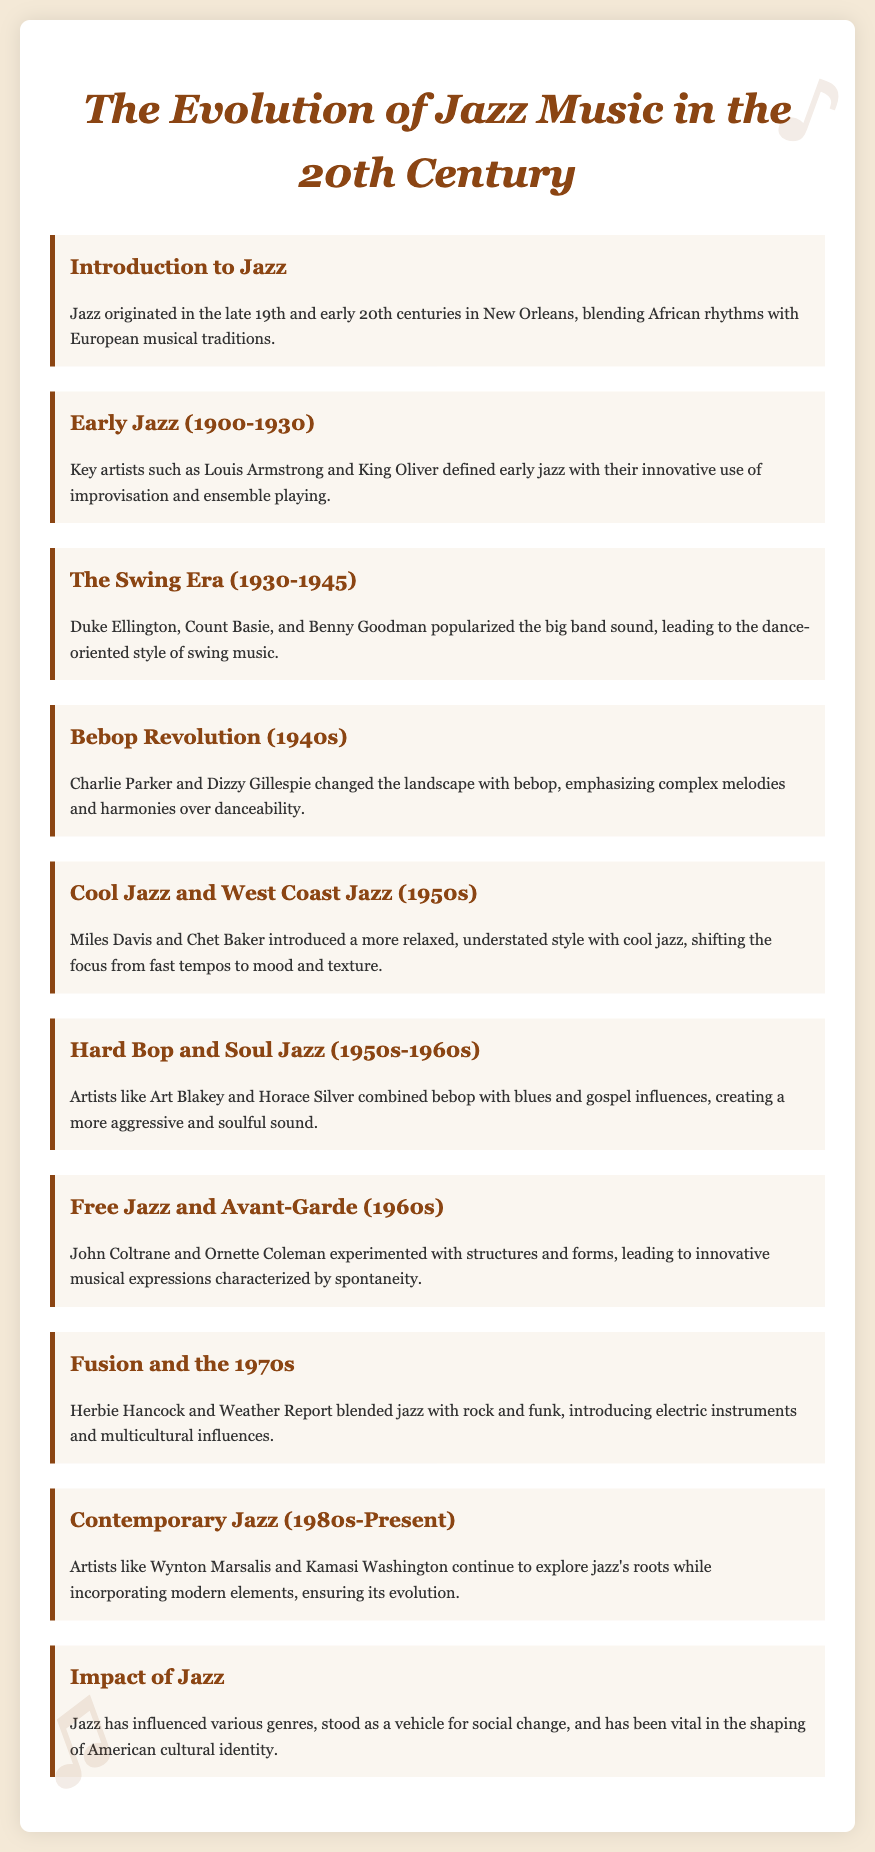What is the origin city of jazz? The document states that jazz originated in New Orleans.
Answer: New Orleans Who are two key artists of early jazz? The document mentions Louis Armstrong and King Oliver as key artists of early jazz.
Answer: Louis Armstrong and King Oliver What music style did Duke Ellington popularize? Duke Ellington is associated with the big band sound and dance-oriented style of swing music.
Answer: Swing Which two artists are known for the bebop revolution? The document lists Charlie Parker and Dizzy Gillespie as key figures in the bebop revolution.
Answer: Charlie Parker and Dizzy Gillespie What decade is associated with cool jazz? The document indicates that cool jazz emerged in the 1950s.
Answer: 1950s What musical elements did Herbie Hancock introduce in the 1970s? Herbie Hancock blended jazz with rock and funk and introduced electric instruments and multicultural influences.
Answer: Electric instruments and multicultural influences Name an artist linked to contemporary jazz. The document mentions Wynton Marsalis as a contemporary jazz artist.
Answer: Wynton Marsalis How has jazz influenced culture? Jazz is noted as a vehicle for social change and vital in shaping American cultural identity.
Answer: Social change and American cultural identity 